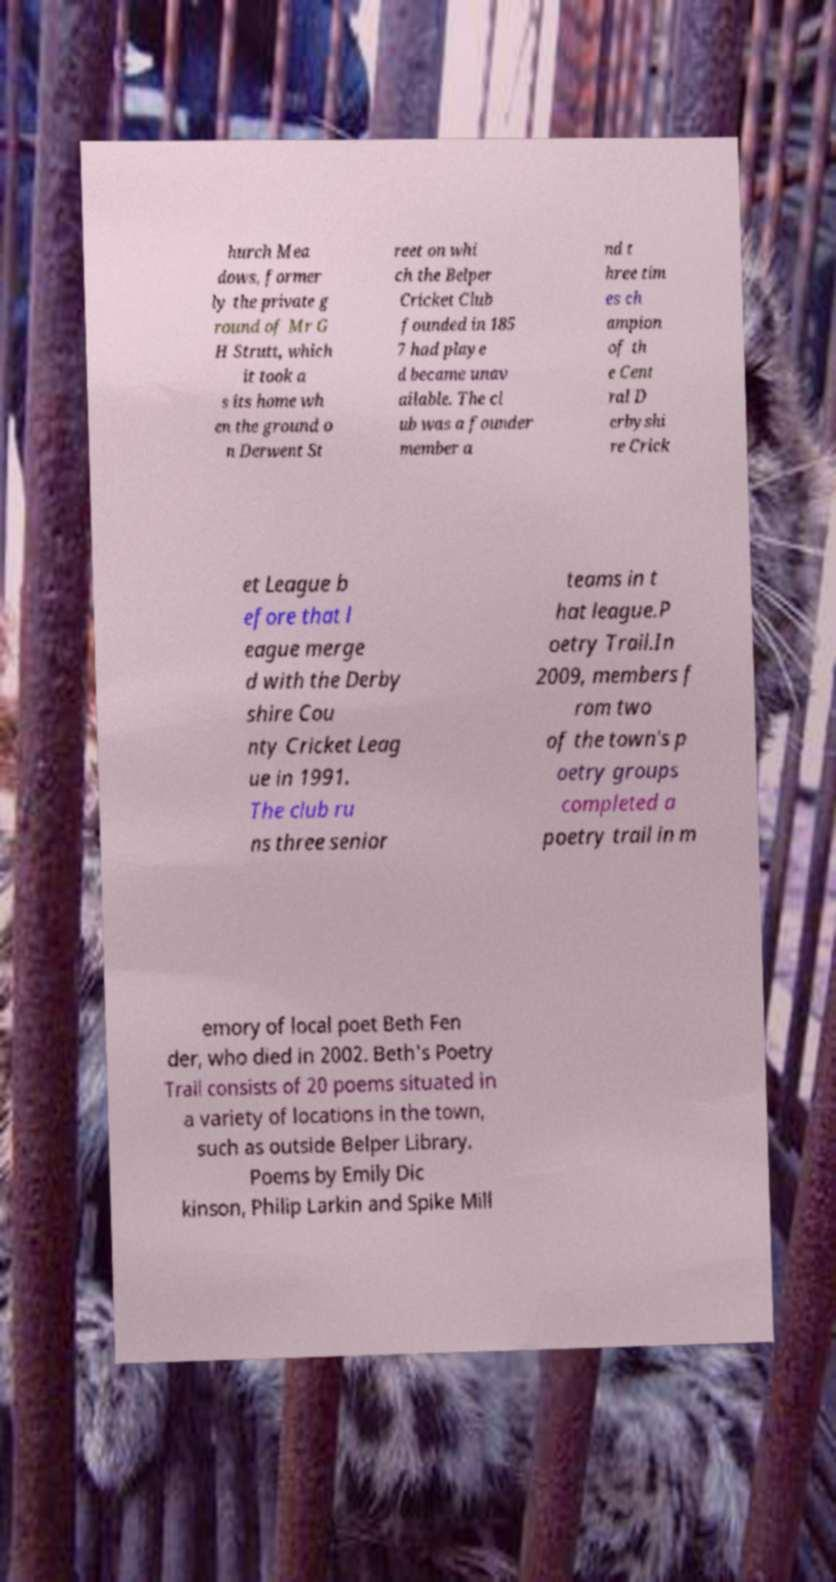There's text embedded in this image that I need extracted. Can you transcribe it verbatim? hurch Mea dows, former ly the private g round of Mr G H Strutt, which it took a s its home wh en the ground o n Derwent St reet on whi ch the Belper Cricket Club founded in 185 7 had playe d became unav ailable. The cl ub was a founder member a nd t hree tim es ch ampion of th e Cent ral D erbyshi re Crick et League b efore that l eague merge d with the Derby shire Cou nty Cricket Leag ue in 1991. The club ru ns three senior teams in t hat league.P oetry Trail.In 2009, members f rom two of the town's p oetry groups completed a poetry trail in m emory of local poet Beth Fen der, who died in 2002. Beth's Poetry Trail consists of 20 poems situated in a variety of locations in the town, such as outside Belper Library. Poems by Emily Dic kinson, Philip Larkin and Spike Mill 